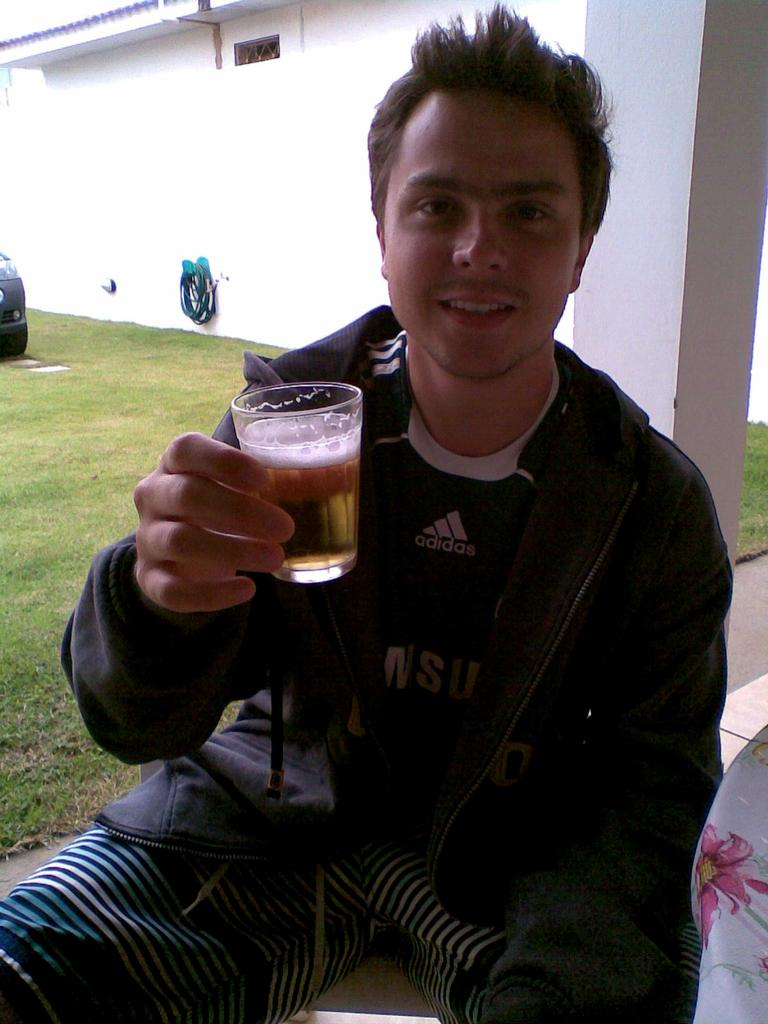Who is present in the image? There is a man in the image. What is the man holding in his hand? The man is holding a glass in his hand. What type of natural environment can be seen in the image? There is grass visible in the image. What architectural features are present in the image? There is a pillar and a wall in the image. What type of feather can be seen floating in the air in the image? There is no feather present in the image; it only features a man, a glass, grass, a pillar, and a wall. 